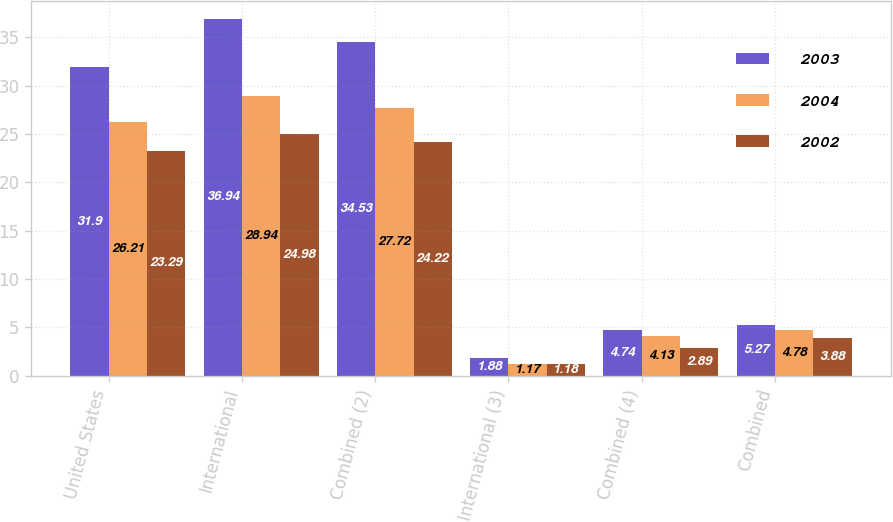<chart> <loc_0><loc_0><loc_500><loc_500><stacked_bar_chart><ecel><fcel>United States<fcel>International<fcel>Combined (2)<fcel>International (3)<fcel>Combined (4)<fcel>Combined<nl><fcel>2003<fcel>31.9<fcel>36.94<fcel>34.53<fcel>1.88<fcel>4.74<fcel>5.27<nl><fcel>2004<fcel>26.21<fcel>28.94<fcel>27.72<fcel>1.17<fcel>4.13<fcel>4.78<nl><fcel>2002<fcel>23.29<fcel>24.98<fcel>24.22<fcel>1.18<fcel>2.89<fcel>3.88<nl></chart> 